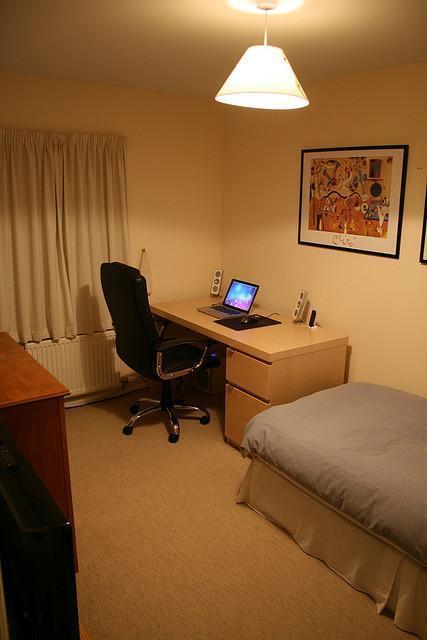How many chairs in the room?
Give a very brief answer. 1. 